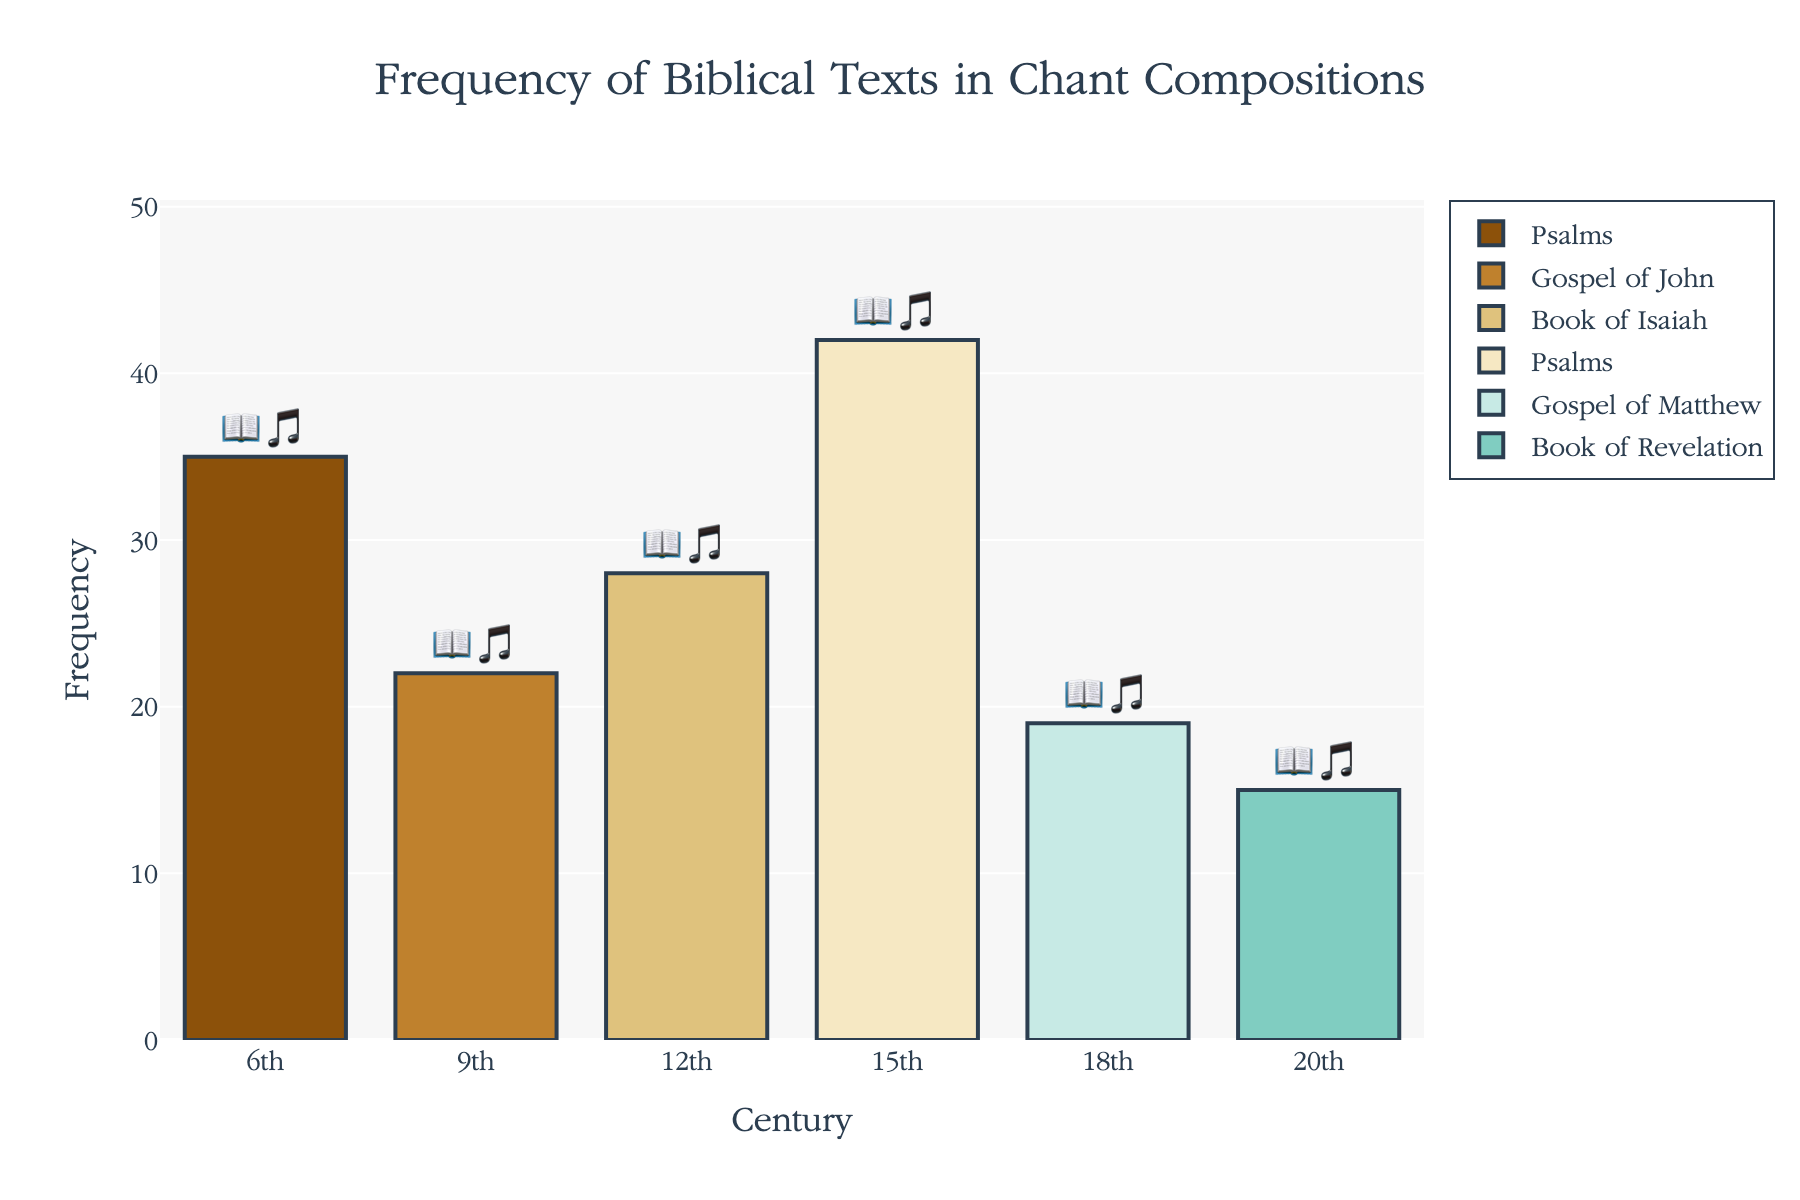What is the title of the figure? The title is usually placed at the top of the figure and it summarizes the main topic of the visualization. Here, it reads "Frequency of Biblical Texts in Chant Compositions".
Answer: Frequency of Biblical Texts in Chant Compositions Which century has the highest frequency of Psalms? By looking at the bars labeled with 📖🎵, we can identify the centuries where Psalms were used and compare their heights. The 15th century has the highest bar for Psalms with a frequency of 42.
Answer: 15th century How many different biblical texts are represented in the 9th century? We identify the century on the x-axis and count the number of unique biblical texts corresponding to that century. The 9th century only shows the Gospel of John.
Answer: 1 What is the frequency of the Book of Revelation in the 20th century? Locate the 20th century on the x-axis and then identify the height of the bar for the Book of Revelation labeled with 📖🎵. The bar reaches a frequency of 15.
Answer: 15 Which century shows the lowest frequency for any biblical text and what is the text? We search for the shortest bar in the entire figure, which corresponds to the Gospel of Matthew with a frequency of 19 in the 18th century.
Answer: 18th century, Gospel of Matthew Compare the use of Psalms in the 6th and 15th centuries. How much did their frequency change? Check the frequency of Psalms in both centuries (35 for the 6th and 42 for the 15th), then calculate the difference: 42 - 35 = 7.
Answer: Increased by 7 What is the average frequency of biblical texts represented in the figure? Add up all the frequencies (35 + 22 + 28 + 42 + 19 + 15 = 161) and divide by the number of texts (6). The average is 161/6 ≈ 26.83.
Answer: 26.83 Which book appears in both the 6th and 15th centuries? Identify the books listed for the 6th and 15th centuries. Both centuries list Psalms as the biblical text.
Answer: Psalms What is the combined frequency of the Gospels of John and Matthew? Add the frequencies of the Gospel of John in the 9th century (22) and the Gospel of Matthew in the 18th century (19): 22 + 19 = 41.
Answer: 41 